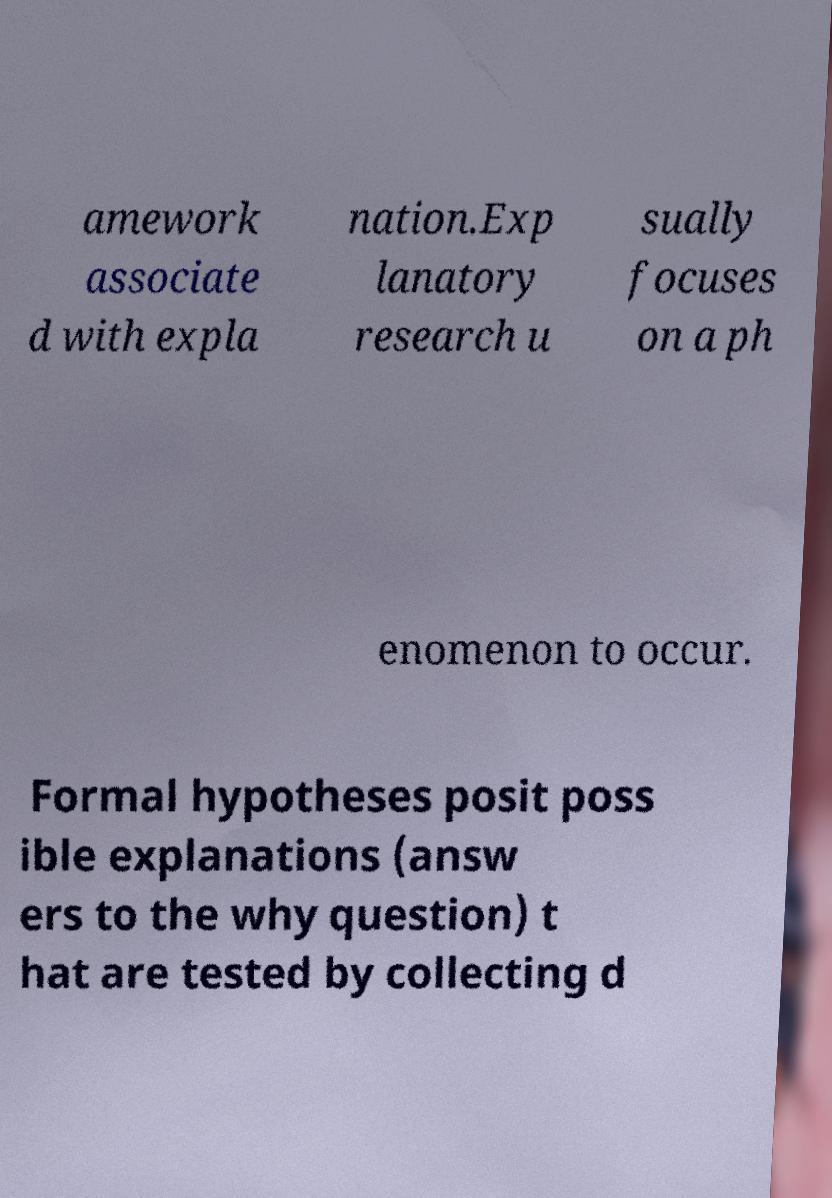I need the written content from this picture converted into text. Can you do that? amework associate d with expla nation.Exp lanatory research u sually focuses on a ph enomenon to occur. Formal hypotheses posit poss ible explanations (answ ers to the why question) t hat are tested by collecting d 